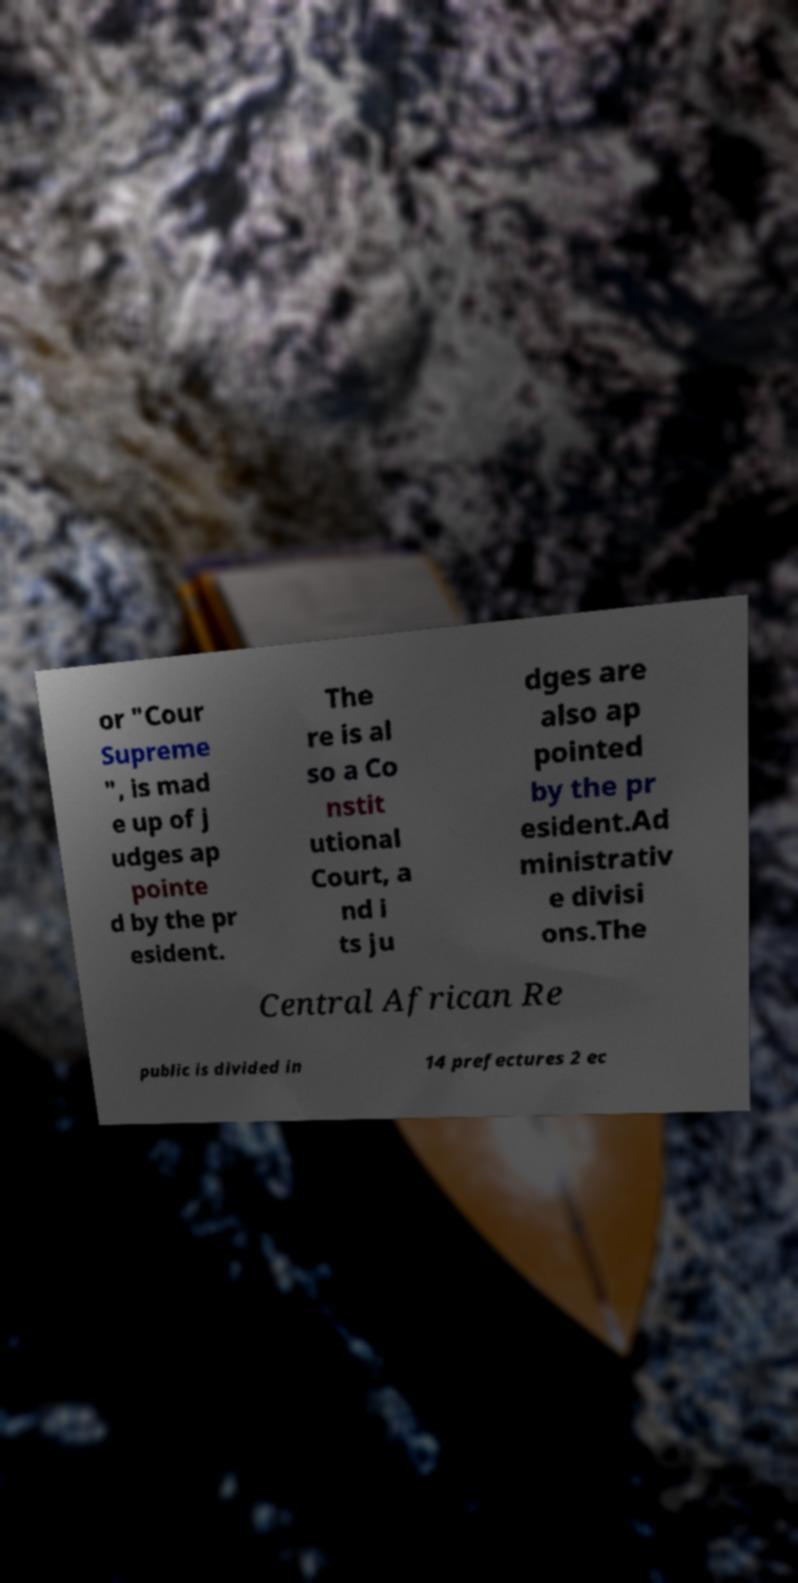Please identify and transcribe the text found in this image. or "Cour Supreme ", is mad e up of j udges ap pointe d by the pr esident. The re is al so a Co nstit utional Court, a nd i ts ju dges are also ap pointed by the pr esident.Ad ministrativ e divisi ons.The Central African Re public is divided in 14 prefectures 2 ec 